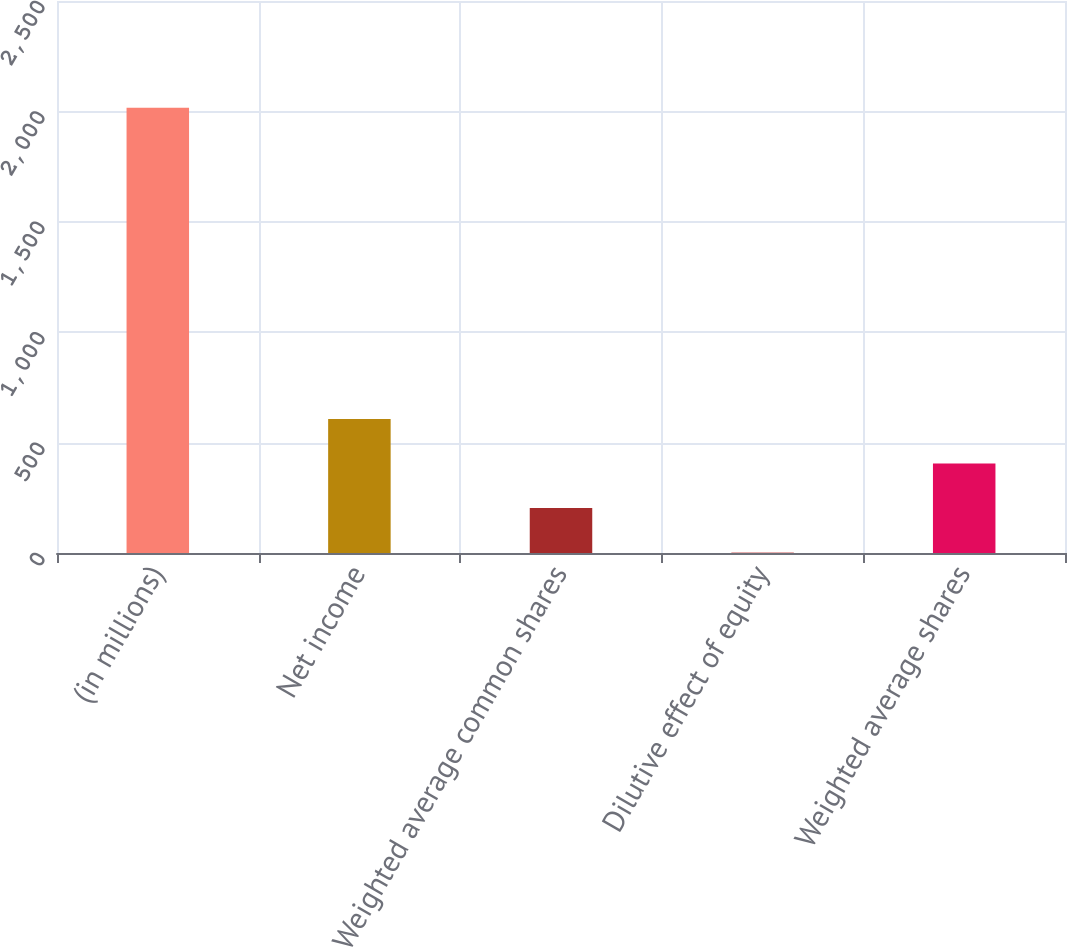<chart> <loc_0><loc_0><loc_500><loc_500><bar_chart><fcel>(in millions)<fcel>Net income<fcel>Weighted average common shares<fcel>Dilutive effect of equity<fcel>Weighted average shares<nl><fcel>2017<fcel>606.43<fcel>203.41<fcel>1.9<fcel>404.92<nl></chart> 